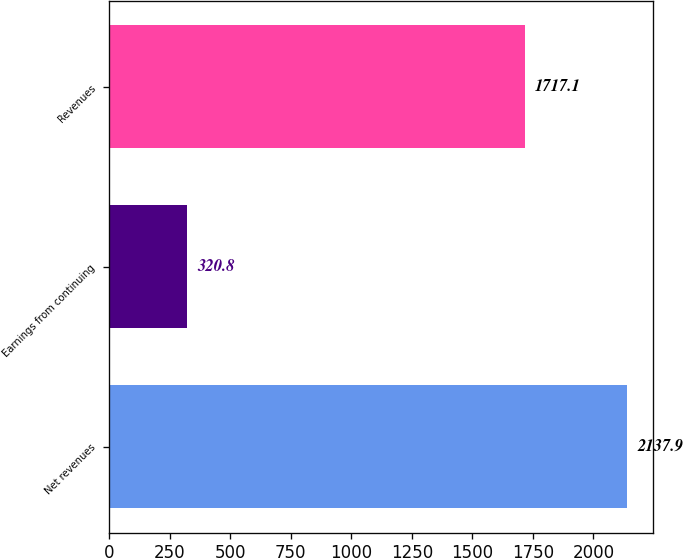<chart> <loc_0><loc_0><loc_500><loc_500><bar_chart><fcel>Net revenues<fcel>Earnings from continuing<fcel>Revenues<nl><fcel>2137.9<fcel>320.8<fcel>1717.1<nl></chart> 